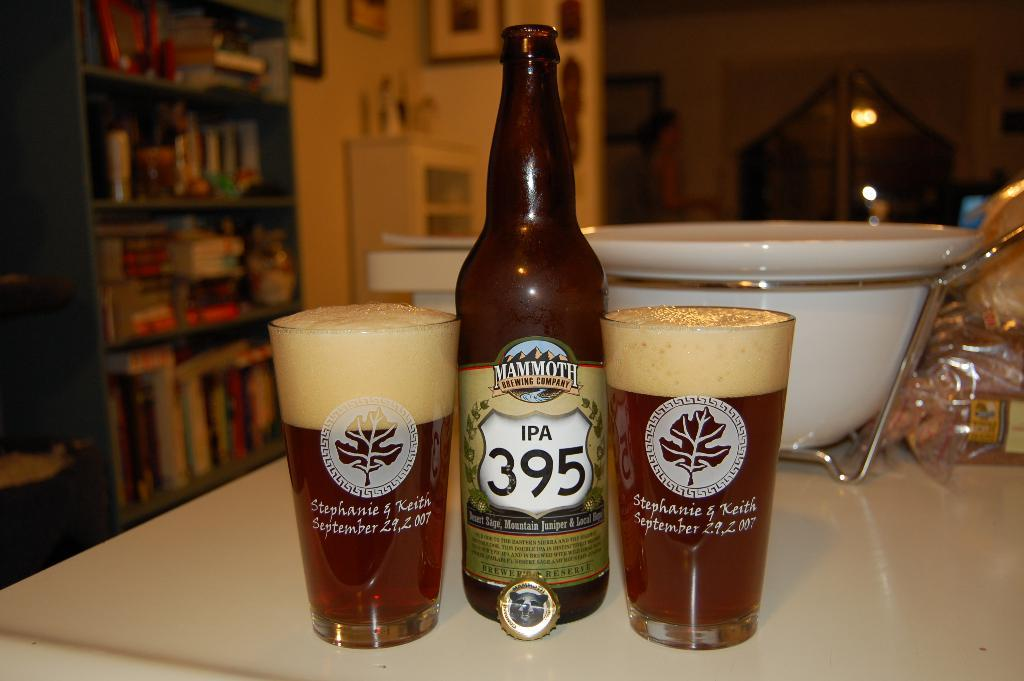<image>
Write a terse but informative summary of the picture. Bottle of IPA 395 in between two full cups of beer. 